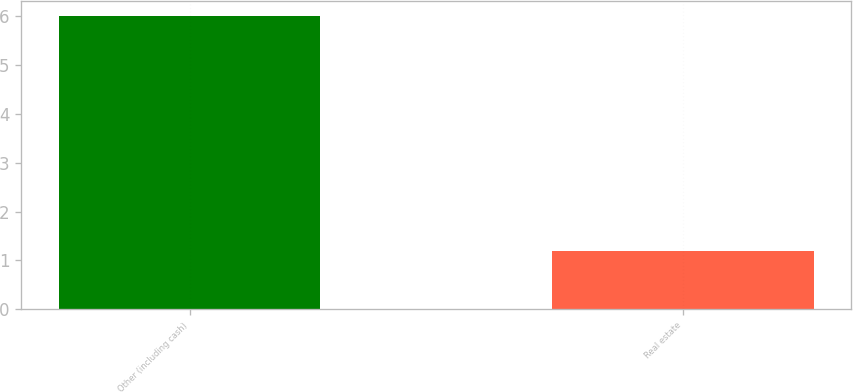<chart> <loc_0><loc_0><loc_500><loc_500><bar_chart><fcel>Other (including cash)<fcel>Real estate<nl><fcel>6<fcel>1.2<nl></chart> 